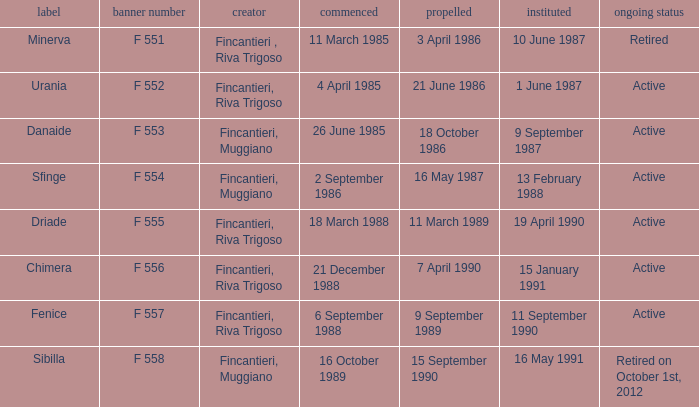What builder launched the name minerva 3 April 1986. 